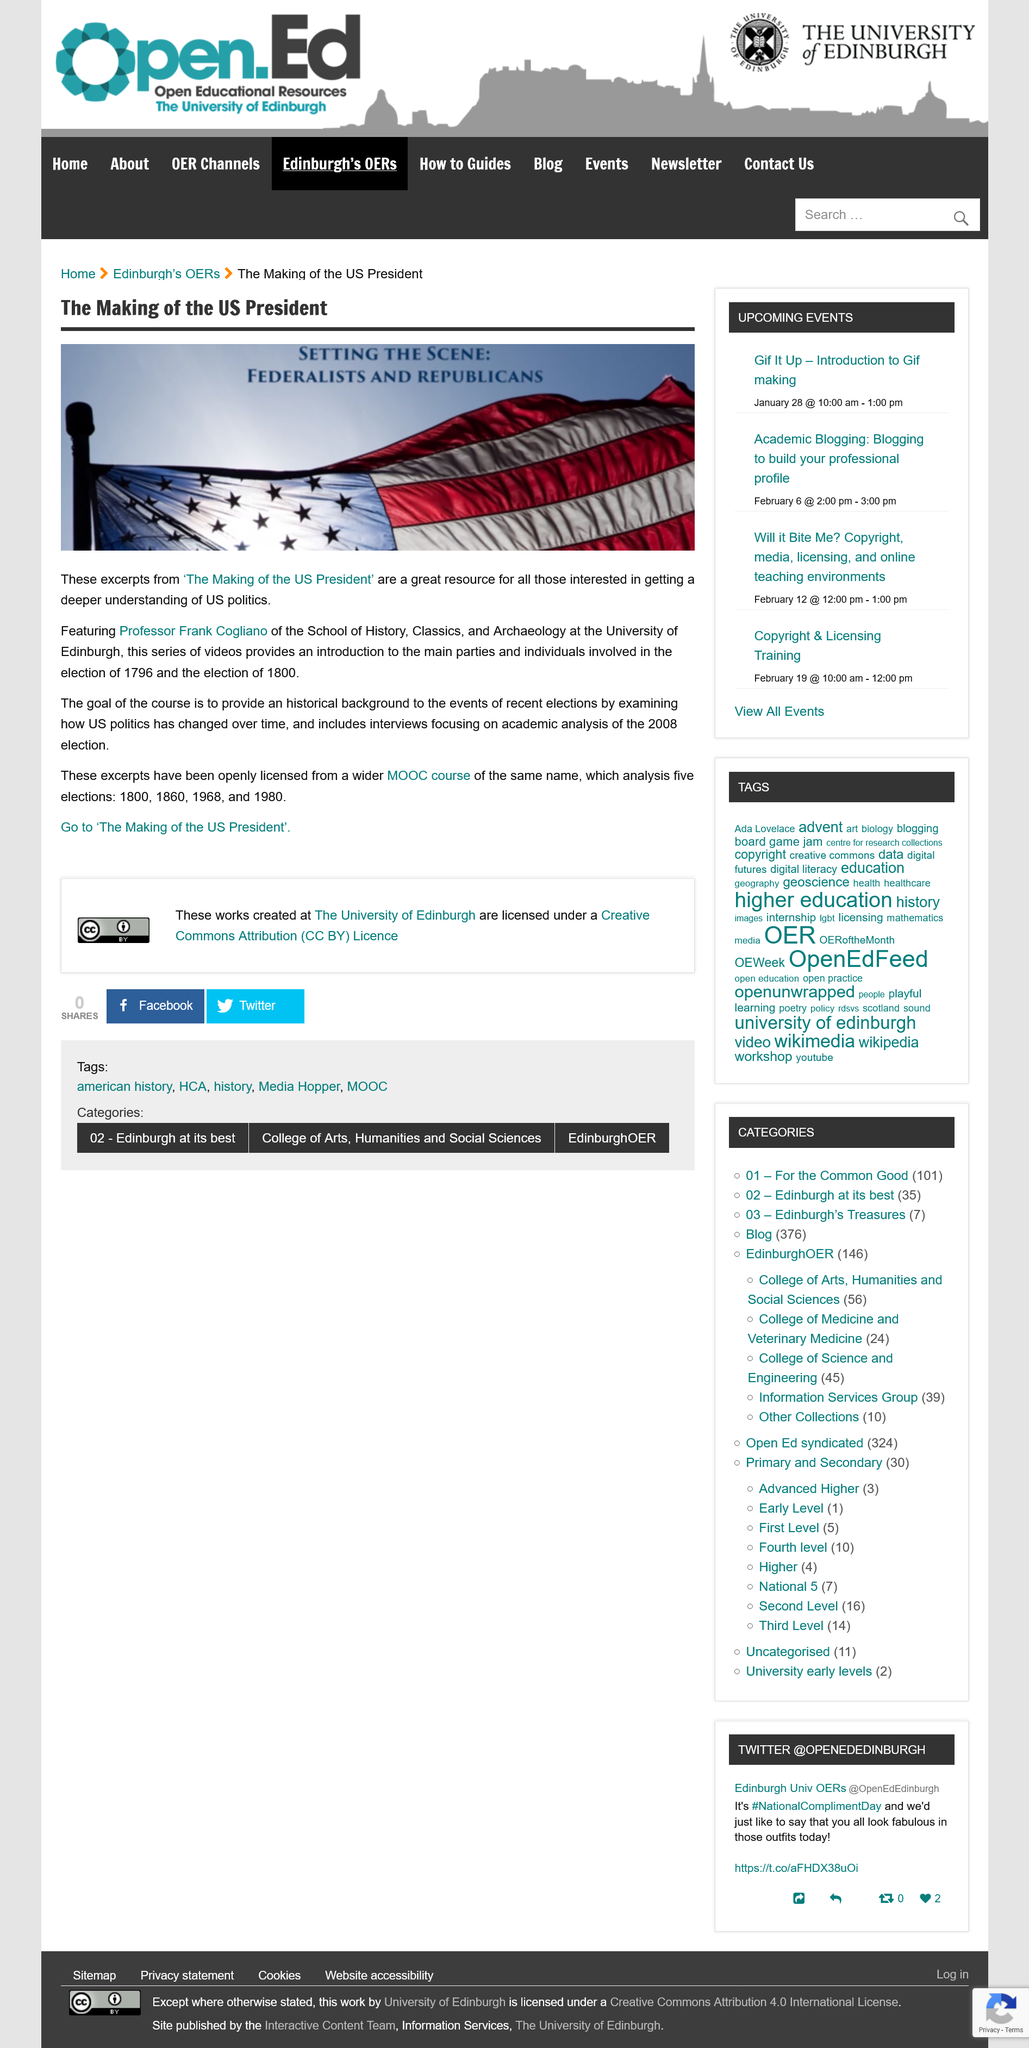Draw attention to some important aspects in this diagram. The goal of this course is to illuminate recent political events by exploring the evolution of US politics over time and gaining a comprehensive understanding of its historical context. The Making of the US President" is a feature that is executed by Professor Frank Cogliano. The excerpts from "The Making of the US President" are a valuable resource for anyone interested in gaining a deeper understanding of US politics. 